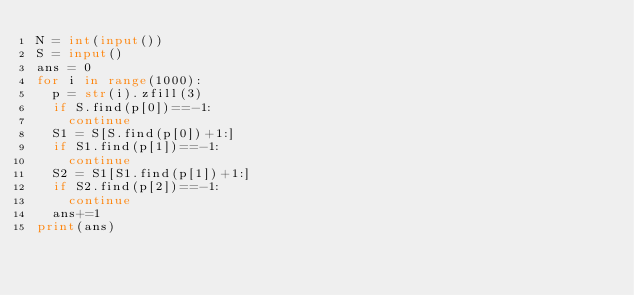<code> <loc_0><loc_0><loc_500><loc_500><_Python_>N = int(input())
S = input()
ans = 0
for i in range(1000):
  p = str(i).zfill(3)
  if S.find(p[0])==-1:
    continue
  S1 = S[S.find(p[0])+1:]
  if S1.find(p[1])==-1:
    continue
  S2 = S1[S1.find(p[1])+1:]
  if S2.find(p[2])==-1:
    continue
  ans+=1
print(ans)</code> 